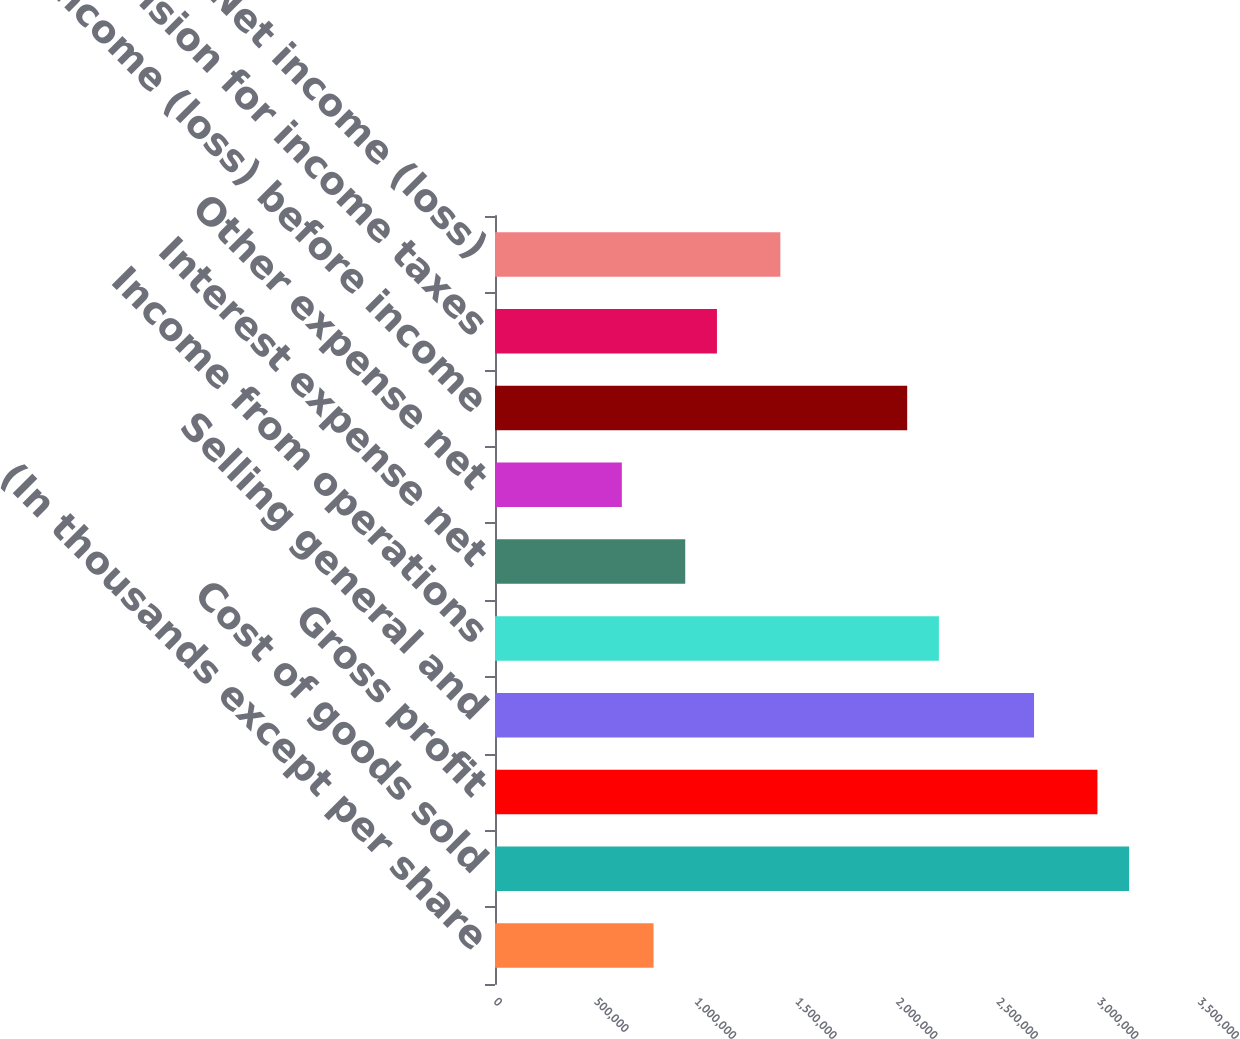Convert chart to OTSL. <chart><loc_0><loc_0><loc_500><loc_500><bar_chart><fcel>(In thousands except per share<fcel>Cost of goods sold<fcel>Gross profit<fcel>Selling general and<fcel>Income from operations<fcel>Interest expense net<fcel>Other expense net<fcel>Income (loss) before income<fcel>Provision for income taxes<fcel>Net income (loss)<nl><fcel>788185<fcel>3.15274e+06<fcel>2.9951e+06<fcel>2.67983e+06<fcel>2.20692e+06<fcel>945822<fcel>630548<fcel>2.04928e+06<fcel>1.10346e+06<fcel>1.41873e+06<nl></chart> 